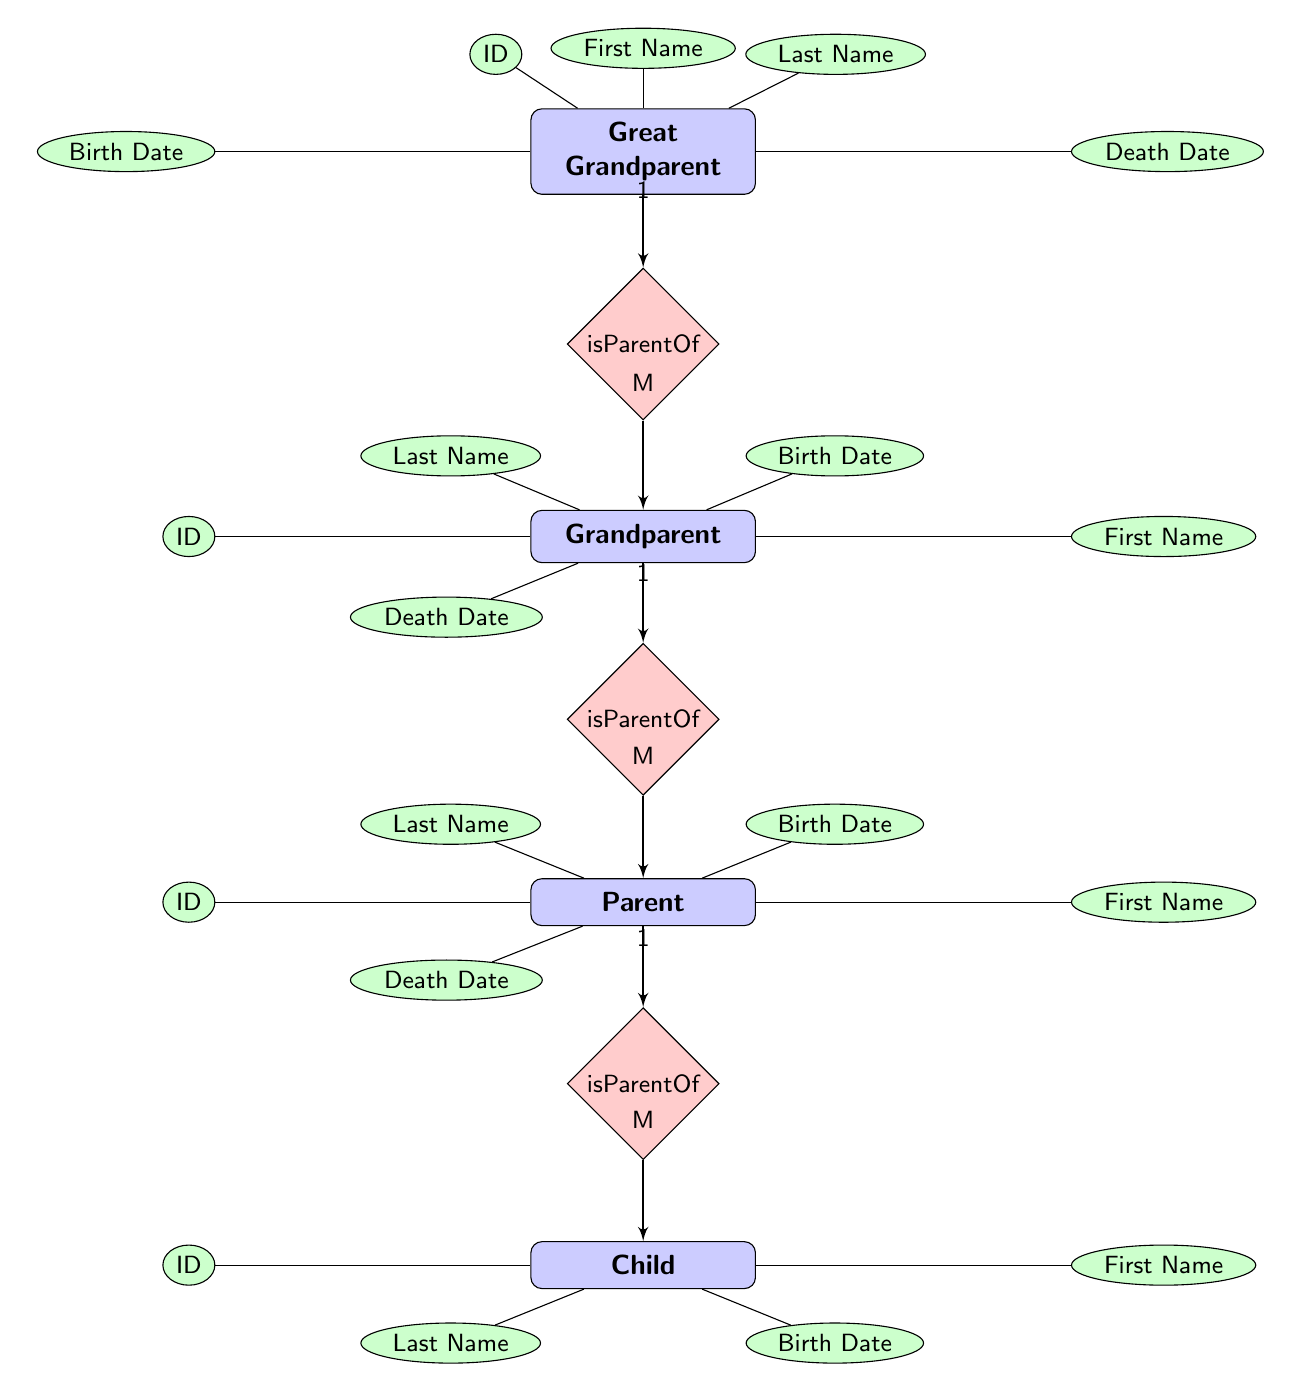What is the maximum number of children a Grandparent can have? According to the diagram, the relationship "isParentOf" indicates that one Grandparent can be related to multiple Parents (Many-to-One cardinality). Therefore, a Grandparent can have multiple children represented by their Parents.
Answer: Many What is the relationship type between Parent and Child? The diagram specifies the relationship "isParentOf" between Parent and Child with a One-to-Many cardinality; this means each Parent can have multiple Children.
Answer: isParentOf How many entities are defined in the diagram? The diagram shows four entities: Great Grandparent, Grandparent, Parent, and Child. Therefore, the total count is four.
Answer: 4 What attribute is missing for the Child entity? In the diagram, the Child entity is missing a Death Date attribute, as it only has ID, First Name, Last Name, and Birth Date listed.
Answer: Death Date Which entity is at the topmost position in the diagram hierarchy? By examining the vertical arrangement of the entities in the diagram, the Great Grandparent entity is depicted at the topmost position.
Answer: Great Grandparent How many relationships originate from the Grandparent entity? The Grandparent entity connects to two relationships: "isParentOf" for both the Parent and the Great Grandparent, which indicates that Grandparent is both a parent to a Parent and a child of a Great Grandparent.
Answer: 2 What is the cardinality of the relationship "isChildOf" between Great Grandparent and Grandparent? The relationship "isChildOf" connects Great Grandparent and Grandparent with Many-to-One cardinality. This means multiple Grandparents can exist under one Great Grandparent.
Answer: Many-to-One Which attribute of Parent is positioned directly below "First Name"? The Birth Date attribute is positioned directly below "First Name" in the Parent entity.
Answer: Birth Date How does the diagram depict the relationship between Great Grandparent and Grandparent? The relationship "isParentOf" connects these two entities, indicating that the Great Grandparent is a parent to the Grandparent. The diagram reflects this with an arrow pointing from Great Grandparent to Grandparent.
Answer: isParentOf 